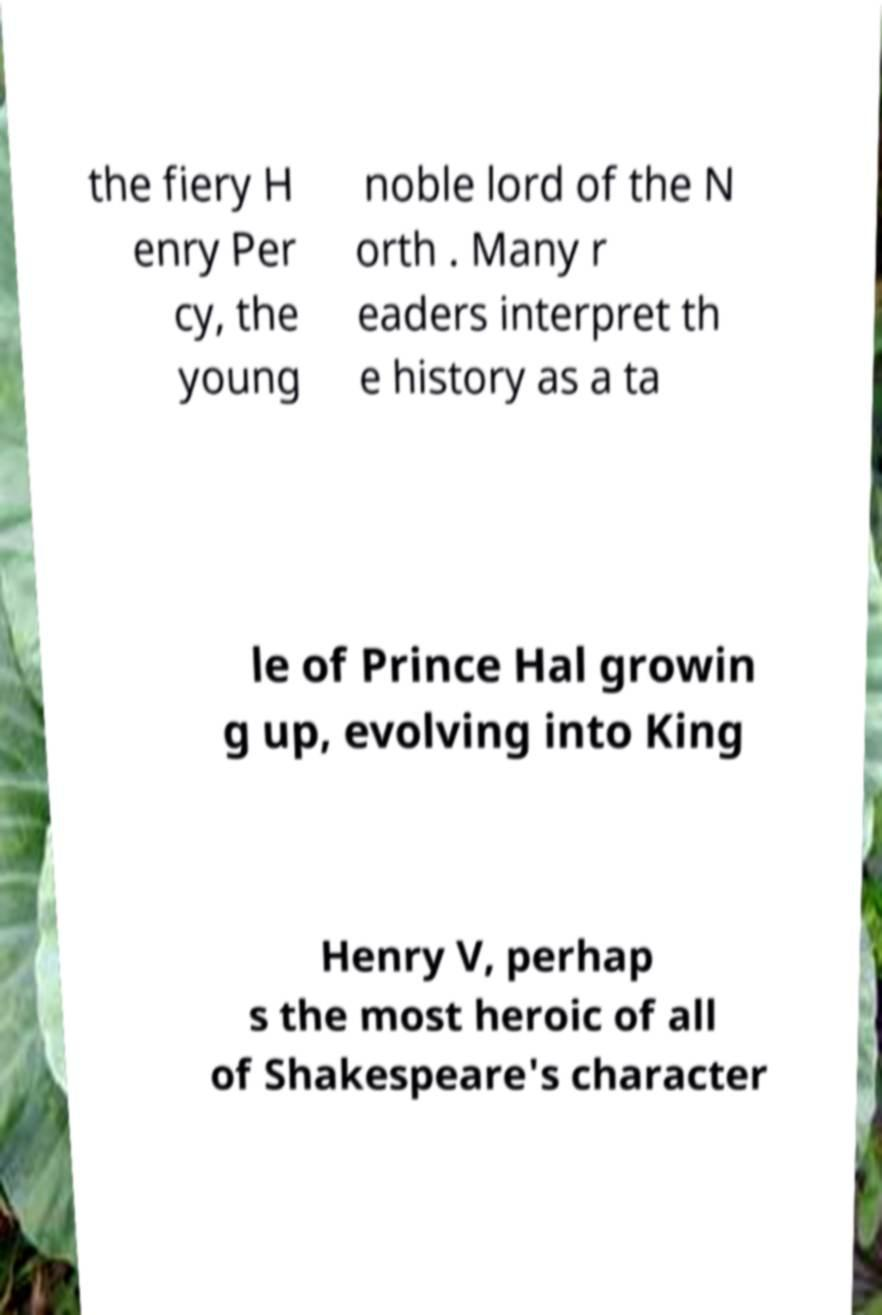There's text embedded in this image that I need extracted. Can you transcribe it verbatim? the fiery H enry Per cy, the young noble lord of the N orth . Many r eaders interpret th e history as a ta le of Prince Hal growin g up, evolving into King Henry V, perhap s the most heroic of all of Shakespeare's character 